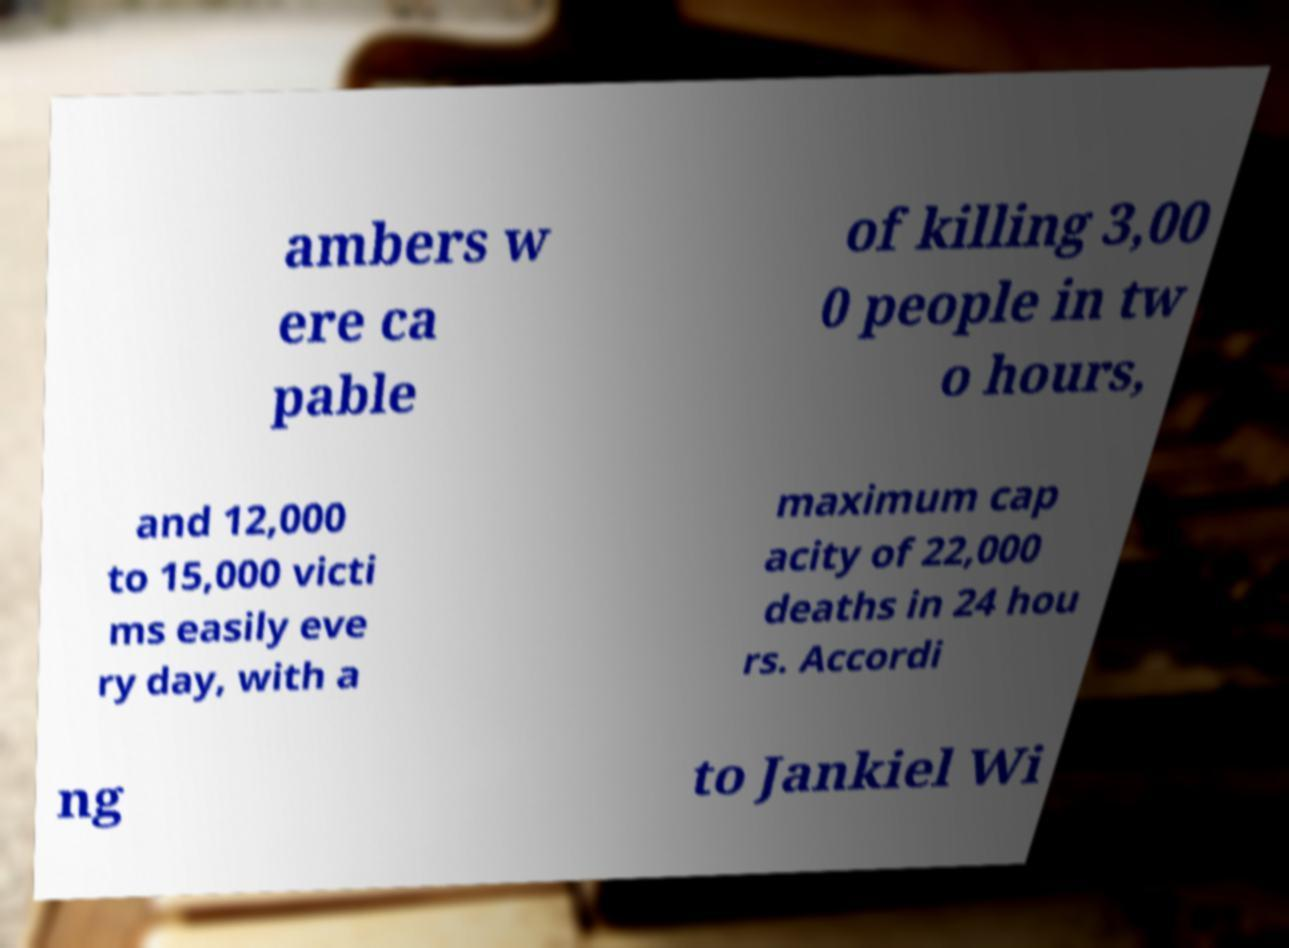Can you accurately transcribe the text from the provided image for me? ambers w ere ca pable of killing 3,00 0 people in tw o hours, and 12,000 to 15,000 victi ms easily eve ry day, with a maximum cap acity of 22,000 deaths in 24 hou rs. Accordi ng to Jankiel Wi 